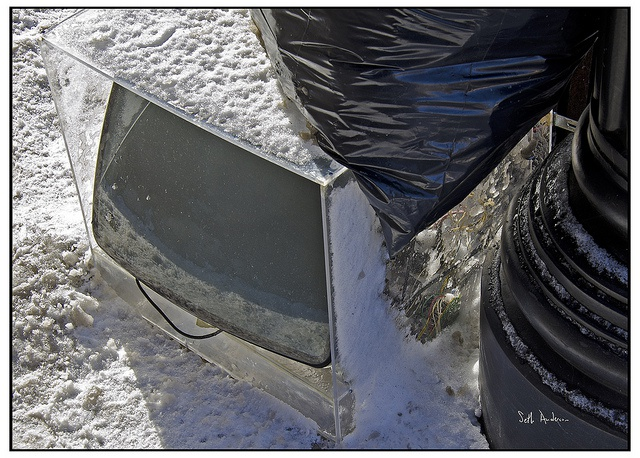Describe the objects in this image and their specific colors. I can see a tv in white, gray, black, and purple tones in this image. 